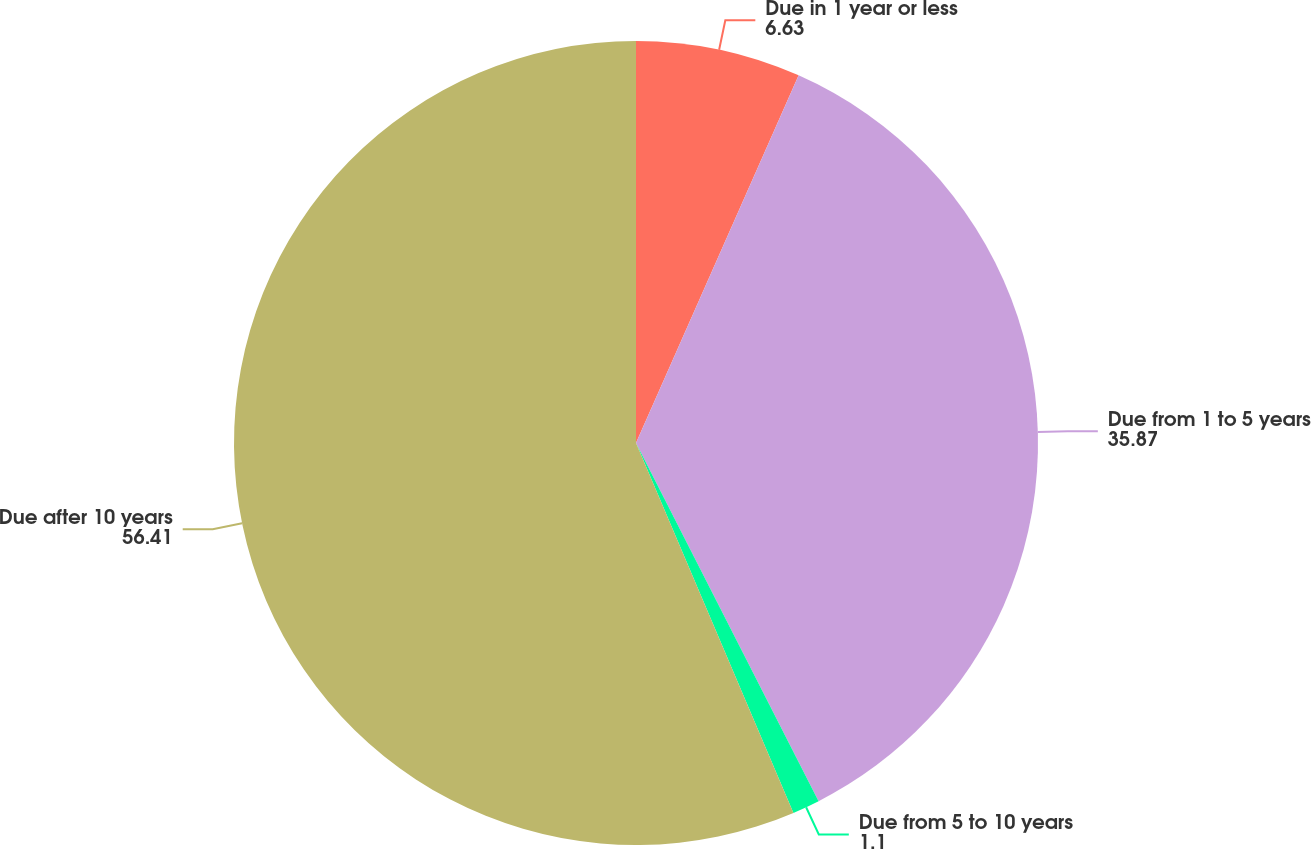<chart> <loc_0><loc_0><loc_500><loc_500><pie_chart><fcel>Due in 1 year or less<fcel>Due from 1 to 5 years<fcel>Due from 5 to 10 years<fcel>Due after 10 years<nl><fcel>6.63%<fcel>35.87%<fcel>1.1%<fcel>56.41%<nl></chart> 